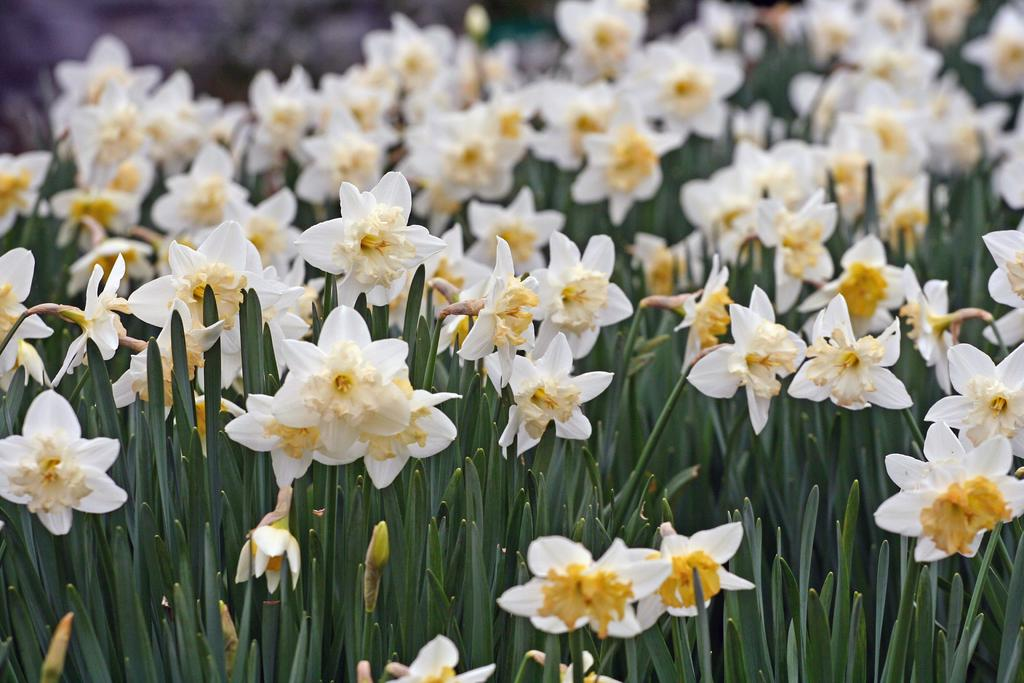What type of plants can be seen in the image? There are plants with flowers in the image. What colors are the flowers? The flowers are in white and yellow colors. Can you describe the background of the image? The background of the image is blurred. What type of square object can be seen on the van in the image? There is no van or square object present in the image; it features plants with flowers and a blurred background. 